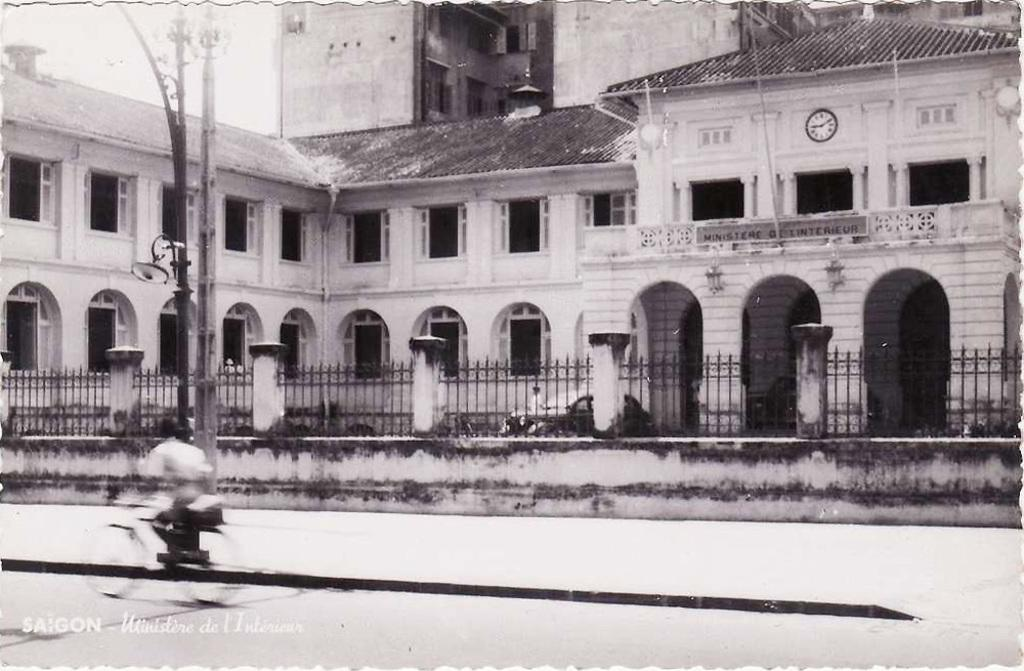What is the person in the image doing? The person is riding a bicycle in the image. Where is the person riding the bicycle? The person is on the road. What can be seen in the background of the image? There is an iron fence, a building, poles, and the sky visible in the background of the image. How many dogs are sorting through the poles in the image? There are no dogs present in the image, and the poles are not being sorted through. 